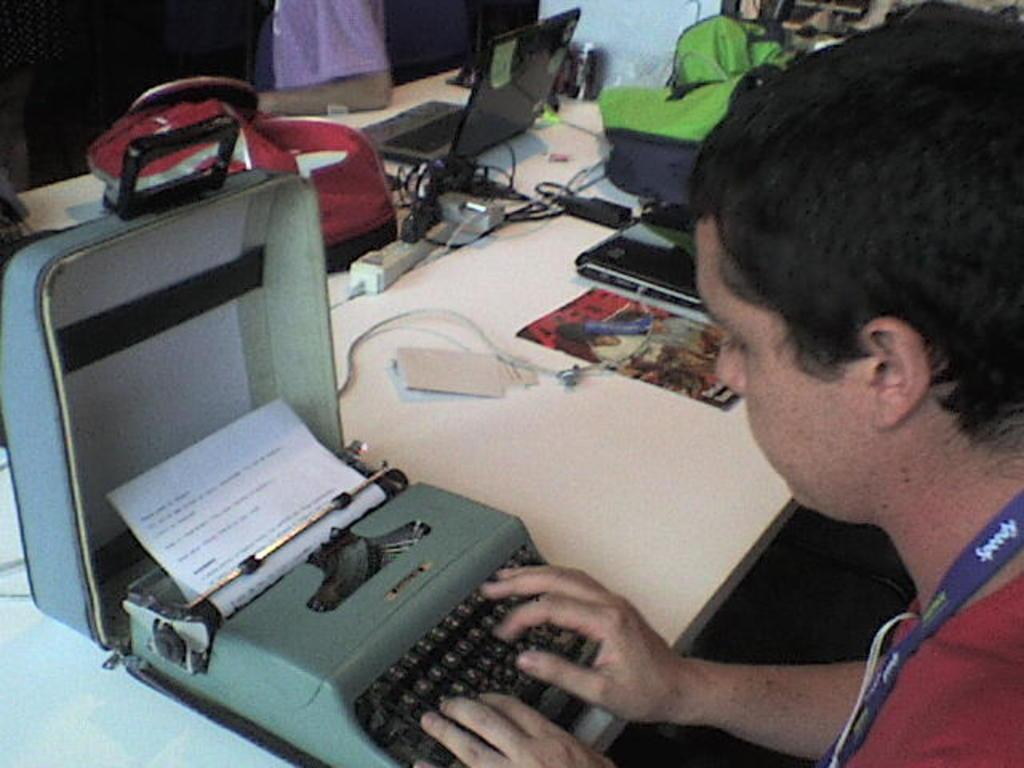What is the man doing in the image? The man is sitting on the right side of the image and typing. What is the man wearing in the image? The man is wearing a red t-shirt in the image. What object is the man using while typing? There is a laptop on a table in the image, which the man is likely using for typing. What type of sign can be seen in the image? There is no sign present in the image. How many trees are visible in the image? There are no trees visible in the image. 